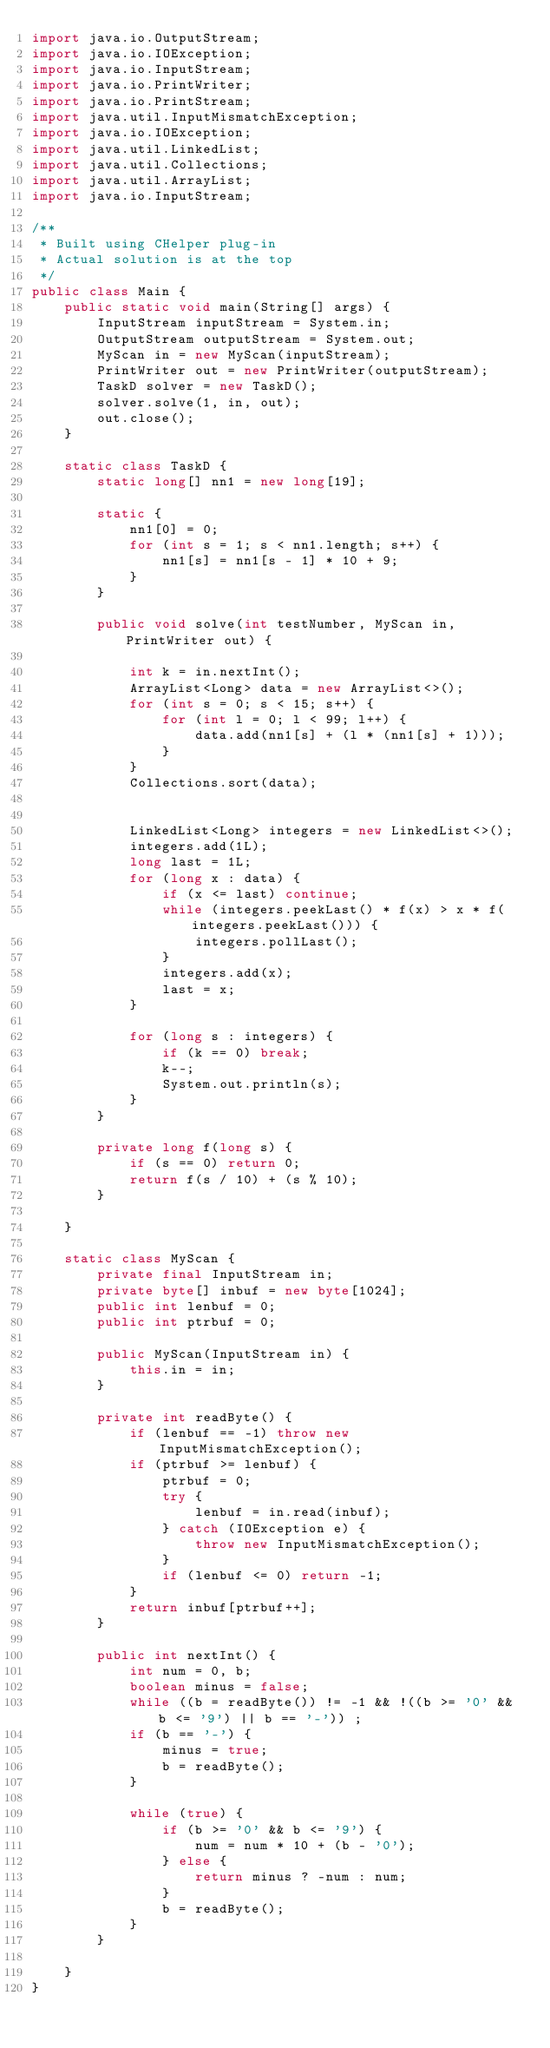Convert code to text. <code><loc_0><loc_0><loc_500><loc_500><_Java_>import java.io.OutputStream;
import java.io.IOException;
import java.io.InputStream;
import java.io.PrintWriter;
import java.io.PrintStream;
import java.util.InputMismatchException;
import java.io.IOException;
import java.util.LinkedList;
import java.util.Collections;
import java.util.ArrayList;
import java.io.InputStream;

/**
 * Built using CHelper plug-in
 * Actual solution is at the top
 */
public class Main {
    public static void main(String[] args) {
        InputStream inputStream = System.in;
        OutputStream outputStream = System.out;
        MyScan in = new MyScan(inputStream);
        PrintWriter out = new PrintWriter(outputStream);
        TaskD solver = new TaskD();
        solver.solve(1, in, out);
        out.close();
    }

    static class TaskD {
        static long[] nn1 = new long[19];

        static {
            nn1[0] = 0;
            for (int s = 1; s < nn1.length; s++) {
                nn1[s] = nn1[s - 1] * 10 + 9;
            }
        }

        public void solve(int testNumber, MyScan in, PrintWriter out) {

            int k = in.nextInt();
            ArrayList<Long> data = new ArrayList<>();
            for (int s = 0; s < 15; s++) {
                for (int l = 0; l < 99; l++) {
                    data.add(nn1[s] + (l * (nn1[s] + 1)));
                }
            }
            Collections.sort(data);


            LinkedList<Long> integers = new LinkedList<>();
            integers.add(1L);
            long last = 1L;
            for (long x : data) {
                if (x <= last) continue;
                while (integers.peekLast() * f(x) > x * f(integers.peekLast())) {
                    integers.pollLast();
                }
                integers.add(x);
                last = x;
            }

            for (long s : integers) {
                if (k == 0) break;
                k--;
                System.out.println(s);
            }
        }

        private long f(long s) {
            if (s == 0) return 0;
            return f(s / 10) + (s % 10);
        }

    }

    static class MyScan {
        private final InputStream in;
        private byte[] inbuf = new byte[1024];
        public int lenbuf = 0;
        public int ptrbuf = 0;

        public MyScan(InputStream in) {
            this.in = in;
        }

        private int readByte() {
            if (lenbuf == -1) throw new InputMismatchException();
            if (ptrbuf >= lenbuf) {
                ptrbuf = 0;
                try {
                    lenbuf = in.read(inbuf);
                } catch (IOException e) {
                    throw new InputMismatchException();
                }
                if (lenbuf <= 0) return -1;
            }
            return inbuf[ptrbuf++];
        }

        public int nextInt() {
            int num = 0, b;
            boolean minus = false;
            while ((b = readByte()) != -1 && !((b >= '0' && b <= '9') || b == '-')) ;
            if (b == '-') {
                minus = true;
                b = readByte();
            }

            while (true) {
                if (b >= '0' && b <= '9') {
                    num = num * 10 + (b - '0');
                } else {
                    return minus ? -num : num;
                }
                b = readByte();
            }
        }

    }
}

</code> 